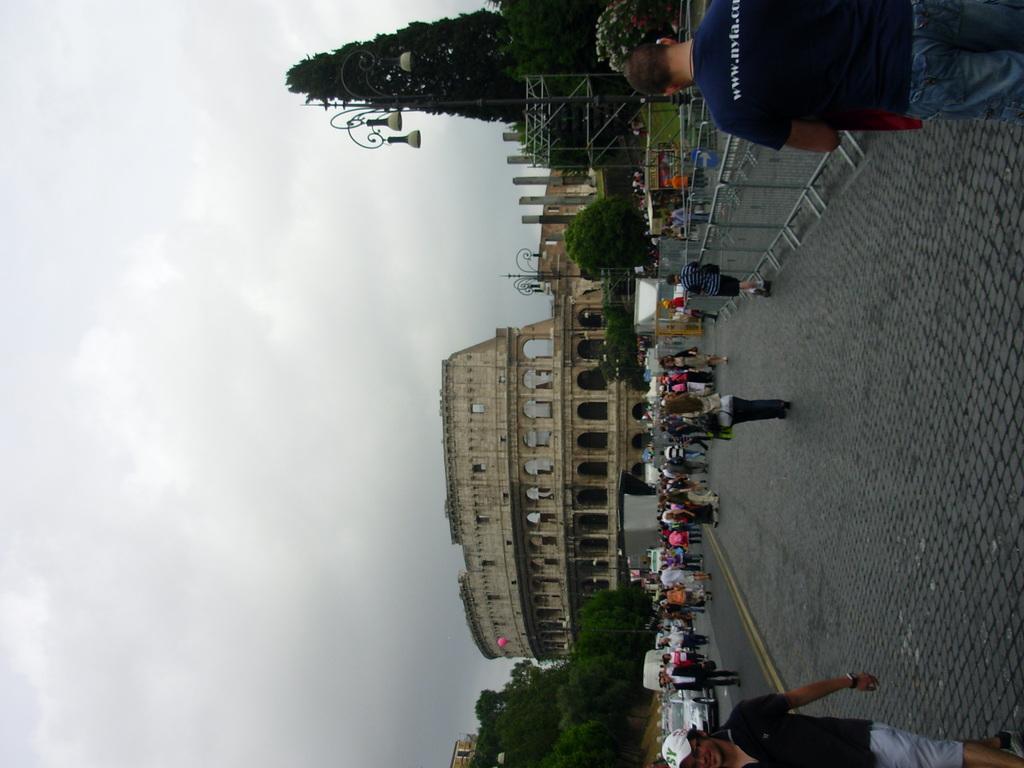Can you describe this image briefly? In the center of the picture there are trees, street lights, people, buildings, railing, the Colosseum and other objects. On the right there are people and pavement. On the left it is sky. 